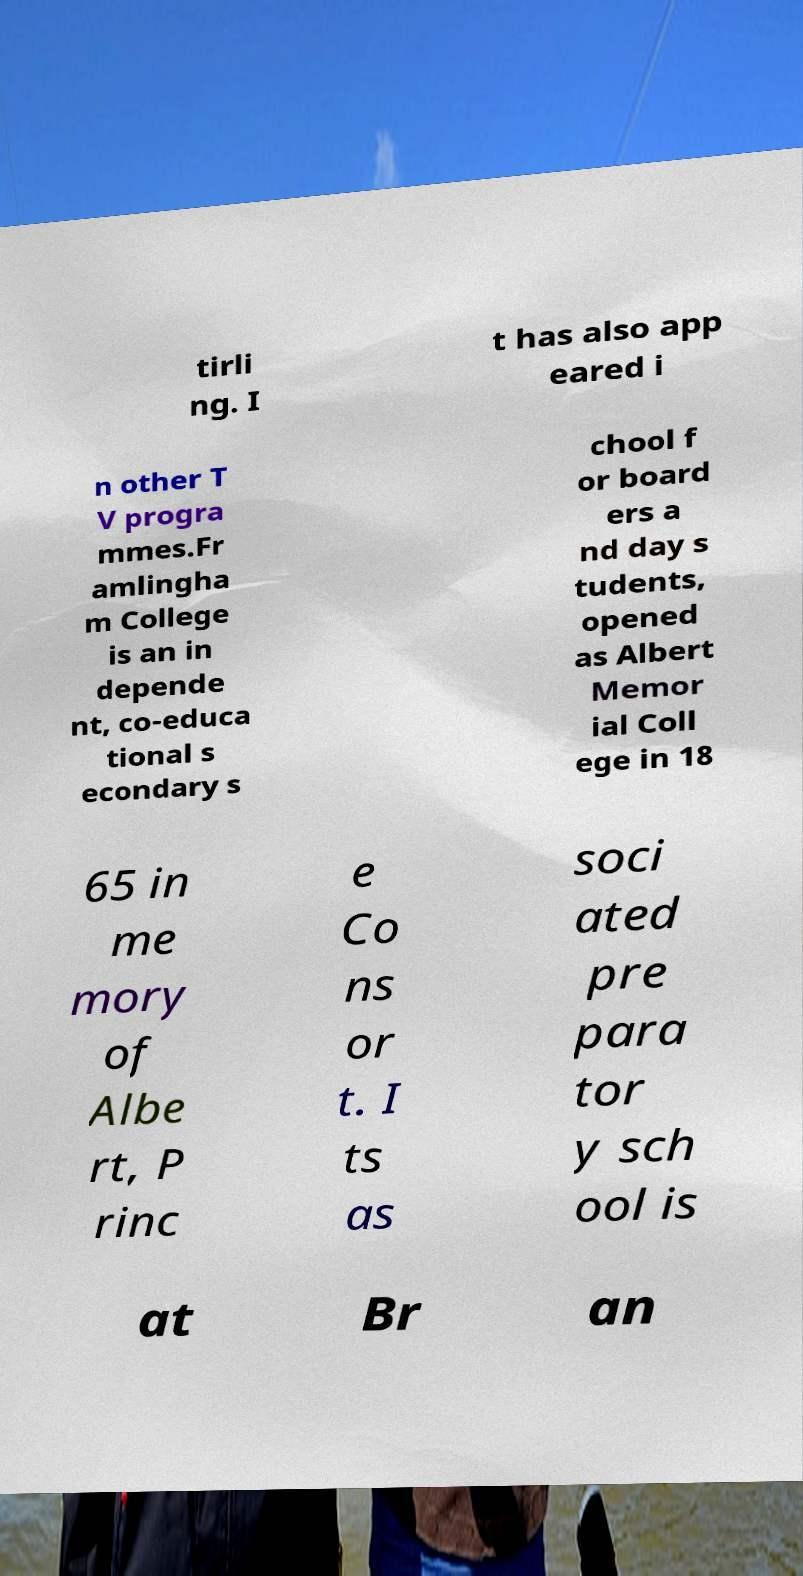Could you extract and type out the text from this image? tirli ng. I t has also app eared i n other T V progra mmes.Fr amlingha m College is an in depende nt, co-educa tional s econdary s chool f or board ers a nd day s tudents, opened as Albert Memor ial Coll ege in 18 65 in me mory of Albe rt, P rinc e Co ns or t. I ts as soci ated pre para tor y sch ool is at Br an 